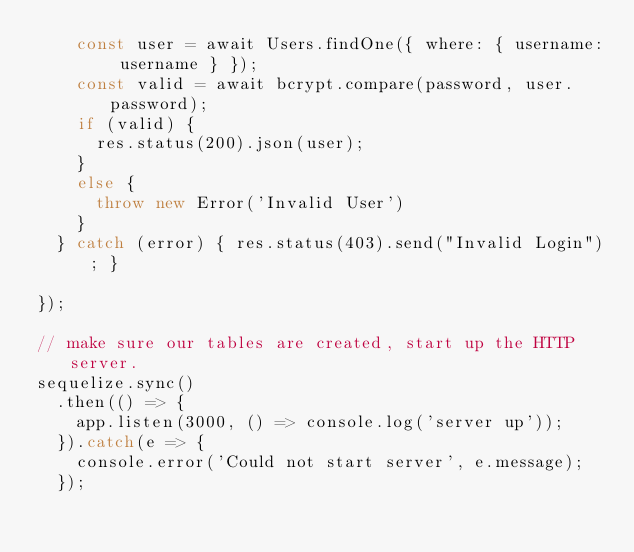<code> <loc_0><loc_0><loc_500><loc_500><_JavaScript_>    const user = await Users.findOne({ where: { username: username } });
    const valid = await bcrypt.compare(password, user.password);
    if (valid) {
      res.status(200).json(user);
    }
    else {
      throw new Error('Invalid User')
    }
  } catch (error) { res.status(403).send("Invalid Login"); }

});

// make sure our tables are created, start up the HTTP server.
sequelize.sync()
  .then(() => {
    app.listen(3000, () => console.log('server up'));
  }).catch(e => {
    console.error('Could not start server', e.message);
  });</code> 